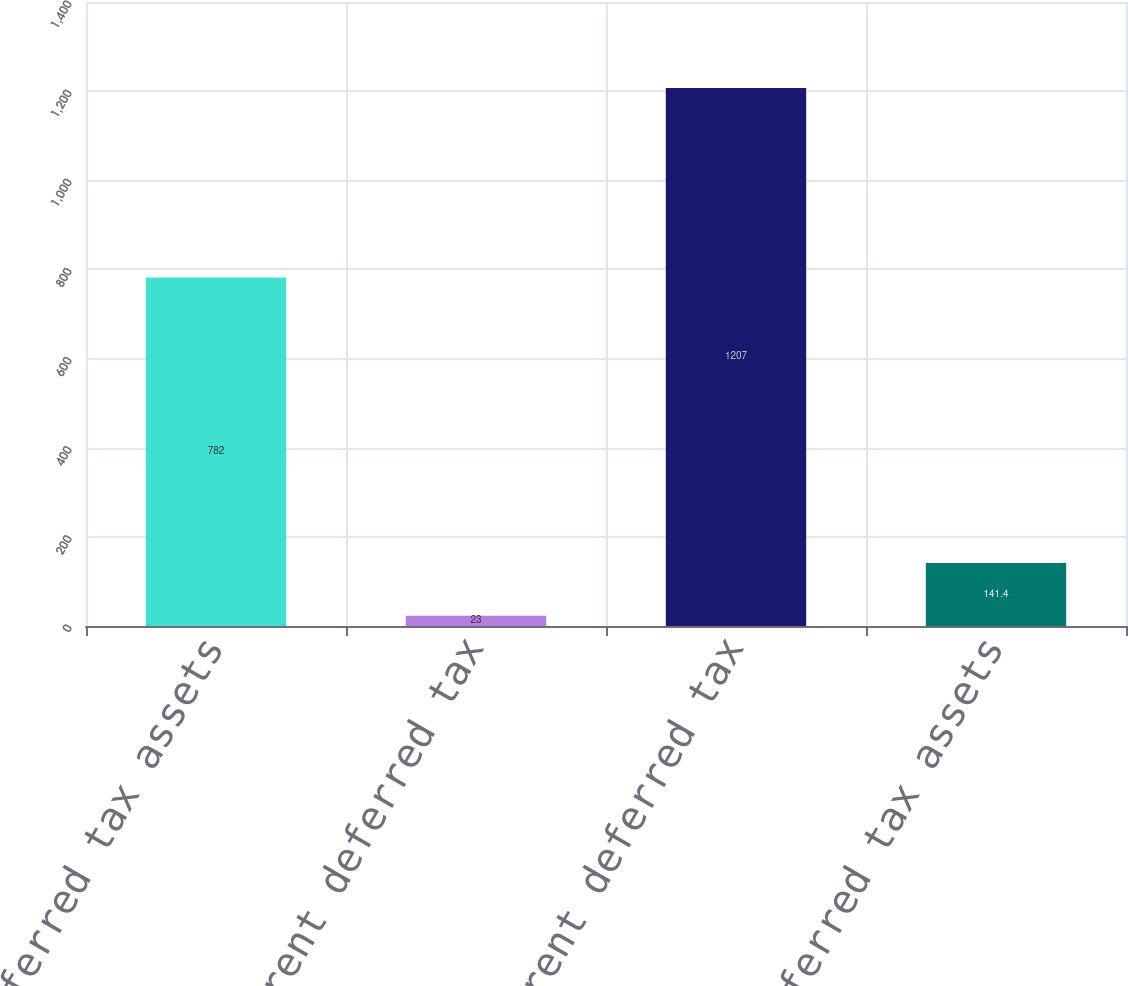Convert chart. <chart><loc_0><loc_0><loc_500><loc_500><bar_chart><fcel>Current deferred tax assets<fcel>Current deferred tax<fcel>Non-current deferred tax<fcel>Net deferred tax assets<nl><fcel>782<fcel>23<fcel>1207<fcel>141.4<nl></chart> 